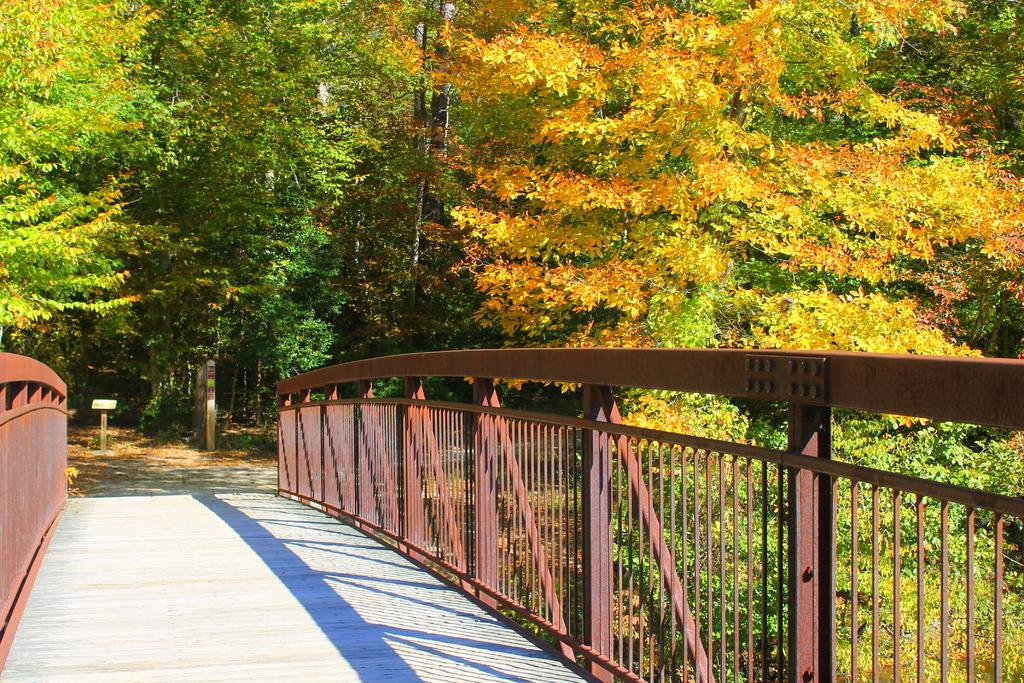What type of natural elements can be seen in the image? There are trees in the image. What structure is present in the image? There is a podium in the image. What architectural feature can be seen in the image? There is a wall in the image. What safety feature is visible in the image? There are railings in the image. What type of tooth is visible on the podium in the image? There is no tooth present on the podium or anywhere else in the image. 